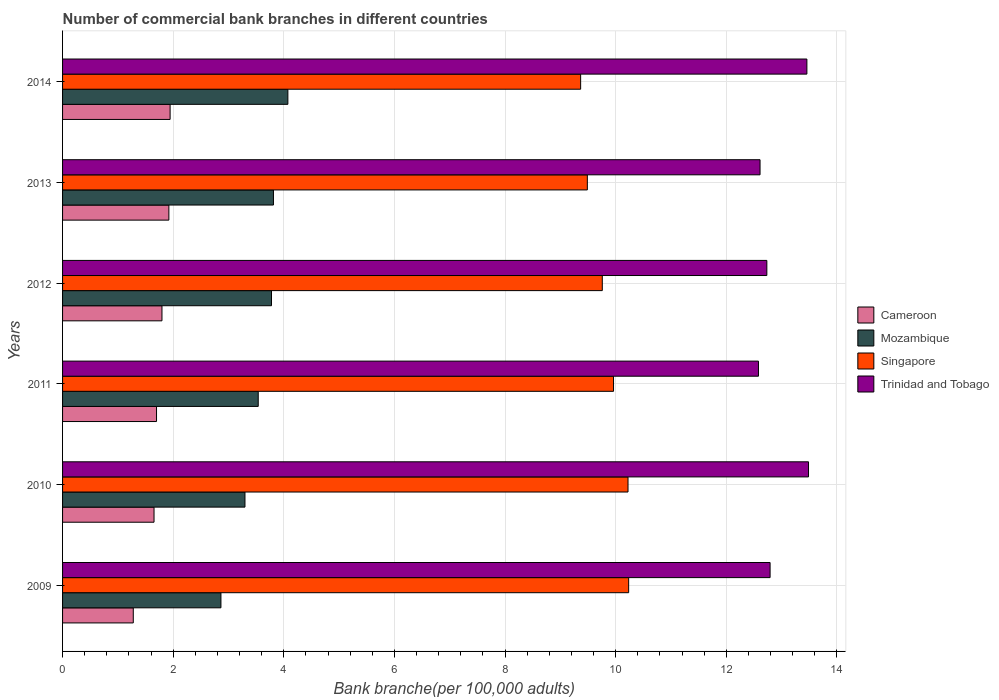How many different coloured bars are there?
Keep it short and to the point. 4. Are the number of bars per tick equal to the number of legend labels?
Provide a succinct answer. Yes. How many bars are there on the 2nd tick from the top?
Provide a succinct answer. 4. How many bars are there on the 2nd tick from the bottom?
Provide a short and direct response. 4. What is the number of commercial bank branches in Singapore in 2009?
Provide a short and direct response. 10.24. Across all years, what is the maximum number of commercial bank branches in Cameroon?
Your answer should be compact. 1.94. Across all years, what is the minimum number of commercial bank branches in Mozambique?
Offer a terse response. 2.86. In which year was the number of commercial bank branches in Singapore maximum?
Offer a terse response. 2009. In which year was the number of commercial bank branches in Mozambique minimum?
Provide a short and direct response. 2009. What is the total number of commercial bank branches in Mozambique in the graph?
Make the answer very short. 21.36. What is the difference between the number of commercial bank branches in Mozambique in 2011 and that in 2014?
Make the answer very short. -0.54. What is the difference between the number of commercial bank branches in Singapore in 2010 and the number of commercial bank branches in Mozambique in 2011?
Give a very brief answer. 6.69. What is the average number of commercial bank branches in Trinidad and Tobago per year?
Keep it short and to the point. 12.94. In the year 2012, what is the difference between the number of commercial bank branches in Trinidad and Tobago and number of commercial bank branches in Cameroon?
Provide a succinct answer. 10.94. In how many years, is the number of commercial bank branches in Singapore greater than 11.6 ?
Ensure brevity in your answer.  0. What is the ratio of the number of commercial bank branches in Trinidad and Tobago in 2009 to that in 2013?
Provide a succinct answer. 1.01. What is the difference between the highest and the second highest number of commercial bank branches in Singapore?
Offer a very short reply. 0.01. What is the difference between the highest and the lowest number of commercial bank branches in Trinidad and Tobago?
Provide a short and direct response. 0.91. In how many years, is the number of commercial bank branches in Mozambique greater than the average number of commercial bank branches in Mozambique taken over all years?
Keep it short and to the point. 3. Is it the case that in every year, the sum of the number of commercial bank branches in Trinidad and Tobago and number of commercial bank branches in Mozambique is greater than the sum of number of commercial bank branches in Singapore and number of commercial bank branches in Cameroon?
Offer a very short reply. Yes. What does the 2nd bar from the top in 2014 represents?
Keep it short and to the point. Singapore. What does the 3rd bar from the bottom in 2012 represents?
Provide a short and direct response. Singapore. How many bars are there?
Offer a terse response. 24. Are all the bars in the graph horizontal?
Provide a succinct answer. Yes. Does the graph contain any zero values?
Offer a very short reply. No. Where does the legend appear in the graph?
Your answer should be compact. Center right. How are the legend labels stacked?
Ensure brevity in your answer.  Vertical. What is the title of the graph?
Offer a very short reply. Number of commercial bank branches in different countries. Does "Afghanistan" appear as one of the legend labels in the graph?
Provide a succinct answer. No. What is the label or title of the X-axis?
Your answer should be very brief. Bank branche(per 100,0 adults). What is the Bank branche(per 100,000 adults) in Cameroon in 2009?
Ensure brevity in your answer.  1.28. What is the Bank branche(per 100,000 adults) of Mozambique in 2009?
Keep it short and to the point. 2.86. What is the Bank branche(per 100,000 adults) of Singapore in 2009?
Ensure brevity in your answer.  10.24. What is the Bank branche(per 100,000 adults) in Trinidad and Tobago in 2009?
Make the answer very short. 12.79. What is the Bank branche(per 100,000 adults) in Cameroon in 2010?
Your response must be concise. 1.65. What is the Bank branche(per 100,000 adults) of Mozambique in 2010?
Your answer should be compact. 3.3. What is the Bank branche(per 100,000 adults) of Singapore in 2010?
Your answer should be very brief. 10.22. What is the Bank branche(per 100,000 adults) of Trinidad and Tobago in 2010?
Your answer should be very brief. 13.49. What is the Bank branche(per 100,000 adults) of Cameroon in 2011?
Give a very brief answer. 1.7. What is the Bank branche(per 100,000 adults) in Mozambique in 2011?
Give a very brief answer. 3.54. What is the Bank branche(per 100,000 adults) in Singapore in 2011?
Give a very brief answer. 9.96. What is the Bank branche(per 100,000 adults) of Trinidad and Tobago in 2011?
Make the answer very short. 12.58. What is the Bank branche(per 100,000 adults) of Cameroon in 2012?
Your answer should be very brief. 1.8. What is the Bank branche(per 100,000 adults) in Mozambique in 2012?
Give a very brief answer. 3.78. What is the Bank branche(per 100,000 adults) in Singapore in 2012?
Offer a very short reply. 9.76. What is the Bank branche(per 100,000 adults) of Trinidad and Tobago in 2012?
Provide a short and direct response. 12.73. What is the Bank branche(per 100,000 adults) in Cameroon in 2013?
Offer a terse response. 1.92. What is the Bank branche(per 100,000 adults) in Mozambique in 2013?
Keep it short and to the point. 3.81. What is the Bank branche(per 100,000 adults) of Singapore in 2013?
Your response must be concise. 9.49. What is the Bank branche(per 100,000 adults) of Trinidad and Tobago in 2013?
Provide a succinct answer. 12.61. What is the Bank branche(per 100,000 adults) of Cameroon in 2014?
Provide a short and direct response. 1.94. What is the Bank branche(per 100,000 adults) in Mozambique in 2014?
Provide a short and direct response. 4.07. What is the Bank branche(per 100,000 adults) in Singapore in 2014?
Ensure brevity in your answer.  9.37. What is the Bank branche(per 100,000 adults) in Trinidad and Tobago in 2014?
Your response must be concise. 13.46. Across all years, what is the maximum Bank branche(per 100,000 adults) of Cameroon?
Give a very brief answer. 1.94. Across all years, what is the maximum Bank branche(per 100,000 adults) of Mozambique?
Give a very brief answer. 4.07. Across all years, what is the maximum Bank branche(per 100,000 adults) in Singapore?
Provide a short and direct response. 10.24. Across all years, what is the maximum Bank branche(per 100,000 adults) in Trinidad and Tobago?
Make the answer very short. 13.49. Across all years, what is the minimum Bank branche(per 100,000 adults) of Cameroon?
Your answer should be compact. 1.28. Across all years, what is the minimum Bank branche(per 100,000 adults) of Mozambique?
Offer a terse response. 2.86. Across all years, what is the minimum Bank branche(per 100,000 adults) of Singapore?
Ensure brevity in your answer.  9.37. Across all years, what is the minimum Bank branche(per 100,000 adults) in Trinidad and Tobago?
Your answer should be very brief. 12.58. What is the total Bank branche(per 100,000 adults) in Cameroon in the graph?
Offer a terse response. 10.3. What is the total Bank branche(per 100,000 adults) in Mozambique in the graph?
Keep it short and to the point. 21.36. What is the total Bank branche(per 100,000 adults) in Singapore in the graph?
Give a very brief answer. 59.03. What is the total Bank branche(per 100,000 adults) in Trinidad and Tobago in the graph?
Provide a succinct answer. 77.66. What is the difference between the Bank branche(per 100,000 adults) in Cameroon in 2009 and that in 2010?
Keep it short and to the point. -0.38. What is the difference between the Bank branche(per 100,000 adults) of Mozambique in 2009 and that in 2010?
Provide a succinct answer. -0.43. What is the difference between the Bank branche(per 100,000 adults) in Singapore in 2009 and that in 2010?
Offer a very short reply. 0.01. What is the difference between the Bank branche(per 100,000 adults) of Trinidad and Tobago in 2009 and that in 2010?
Your response must be concise. -0.69. What is the difference between the Bank branche(per 100,000 adults) in Cameroon in 2009 and that in 2011?
Your answer should be very brief. -0.42. What is the difference between the Bank branche(per 100,000 adults) of Mozambique in 2009 and that in 2011?
Your answer should be very brief. -0.67. What is the difference between the Bank branche(per 100,000 adults) of Singapore in 2009 and that in 2011?
Your response must be concise. 0.27. What is the difference between the Bank branche(per 100,000 adults) in Trinidad and Tobago in 2009 and that in 2011?
Keep it short and to the point. 0.21. What is the difference between the Bank branche(per 100,000 adults) in Cameroon in 2009 and that in 2012?
Make the answer very short. -0.52. What is the difference between the Bank branche(per 100,000 adults) in Mozambique in 2009 and that in 2012?
Offer a very short reply. -0.91. What is the difference between the Bank branche(per 100,000 adults) of Singapore in 2009 and that in 2012?
Give a very brief answer. 0.48. What is the difference between the Bank branche(per 100,000 adults) of Trinidad and Tobago in 2009 and that in 2012?
Your response must be concise. 0.06. What is the difference between the Bank branche(per 100,000 adults) of Cameroon in 2009 and that in 2013?
Provide a short and direct response. -0.64. What is the difference between the Bank branche(per 100,000 adults) of Mozambique in 2009 and that in 2013?
Keep it short and to the point. -0.95. What is the difference between the Bank branche(per 100,000 adults) of Singapore in 2009 and that in 2013?
Give a very brief answer. 0.75. What is the difference between the Bank branche(per 100,000 adults) in Trinidad and Tobago in 2009 and that in 2013?
Provide a succinct answer. 0.18. What is the difference between the Bank branche(per 100,000 adults) of Cameroon in 2009 and that in 2014?
Give a very brief answer. -0.67. What is the difference between the Bank branche(per 100,000 adults) in Mozambique in 2009 and that in 2014?
Offer a terse response. -1.21. What is the difference between the Bank branche(per 100,000 adults) of Singapore in 2009 and that in 2014?
Provide a short and direct response. 0.87. What is the difference between the Bank branche(per 100,000 adults) in Trinidad and Tobago in 2009 and that in 2014?
Provide a short and direct response. -0.67. What is the difference between the Bank branche(per 100,000 adults) in Cameroon in 2010 and that in 2011?
Keep it short and to the point. -0.05. What is the difference between the Bank branche(per 100,000 adults) in Mozambique in 2010 and that in 2011?
Your answer should be compact. -0.24. What is the difference between the Bank branche(per 100,000 adults) in Singapore in 2010 and that in 2011?
Provide a succinct answer. 0.26. What is the difference between the Bank branche(per 100,000 adults) of Trinidad and Tobago in 2010 and that in 2011?
Ensure brevity in your answer.  0.91. What is the difference between the Bank branche(per 100,000 adults) of Cameroon in 2010 and that in 2012?
Offer a very short reply. -0.14. What is the difference between the Bank branche(per 100,000 adults) of Mozambique in 2010 and that in 2012?
Your answer should be very brief. -0.48. What is the difference between the Bank branche(per 100,000 adults) of Singapore in 2010 and that in 2012?
Your answer should be very brief. 0.46. What is the difference between the Bank branche(per 100,000 adults) of Trinidad and Tobago in 2010 and that in 2012?
Your answer should be compact. 0.75. What is the difference between the Bank branche(per 100,000 adults) of Cameroon in 2010 and that in 2013?
Keep it short and to the point. -0.27. What is the difference between the Bank branche(per 100,000 adults) in Mozambique in 2010 and that in 2013?
Offer a very short reply. -0.51. What is the difference between the Bank branche(per 100,000 adults) of Singapore in 2010 and that in 2013?
Make the answer very short. 0.74. What is the difference between the Bank branche(per 100,000 adults) of Trinidad and Tobago in 2010 and that in 2013?
Your answer should be very brief. 0.88. What is the difference between the Bank branche(per 100,000 adults) of Cameroon in 2010 and that in 2014?
Your answer should be compact. -0.29. What is the difference between the Bank branche(per 100,000 adults) in Mozambique in 2010 and that in 2014?
Keep it short and to the point. -0.78. What is the difference between the Bank branche(per 100,000 adults) in Singapore in 2010 and that in 2014?
Provide a succinct answer. 0.86. What is the difference between the Bank branche(per 100,000 adults) of Trinidad and Tobago in 2010 and that in 2014?
Provide a short and direct response. 0.03. What is the difference between the Bank branche(per 100,000 adults) in Cameroon in 2011 and that in 2012?
Provide a succinct answer. -0.1. What is the difference between the Bank branche(per 100,000 adults) of Mozambique in 2011 and that in 2012?
Offer a terse response. -0.24. What is the difference between the Bank branche(per 100,000 adults) in Singapore in 2011 and that in 2012?
Keep it short and to the point. 0.2. What is the difference between the Bank branche(per 100,000 adults) of Trinidad and Tobago in 2011 and that in 2012?
Your answer should be compact. -0.15. What is the difference between the Bank branche(per 100,000 adults) of Cameroon in 2011 and that in 2013?
Ensure brevity in your answer.  -0.22. What is the difference between the Bank branche(per 100,000 adults) in Mozambique in 2011 and that in 2013?
Your answer should be very brief. -0.28. What is the difference between the Bank branche(per 100,000 adults) in Singapore in 2011 and that in 2013?
Your response must be concise. 0.47. What is the difference between the Bank branche(per 100,000 adults) of Trinidad and Tobago in 2011 and that in 2013?
Your answer should be compact. -0.03. What is the difference between the Bank branche(per 100,000 adults) in Cameroon in 2011 and that in 2014?
Provide a short and direct response. -0.25. What is the difference between the Bank branche(per 100,000 adults) of Mozambique in 2011 and that in 2014?
Your response must be concise. -0.54. What is the difference between the Bank branche(per 100,000 adults) of Singapore in 2011 and that in 2014?
Your response must be concise. 0.59. What is the difference between the Bank branche(per 100,000 adults) of Trinidad and Tobago in 2011 and that in 2014?
Give a very brief answer. -0.88. What is the difference between the Bank branche(per 100,000 adults) in Cameroon in 2012 and that in 2013?
Provide a succinct answer. -0.12. What is the difference between the Bank branche(per 100,000 adults) in Mozambique in 2012 and that in 2013?
Provide a succinct answer. -0.04. What is the difference between the Bank branche(per 100,000 adults) in Singapore in 2012 and that in 2013?
Provide a succinct answer. 0.27. What is the difference between the Bank branche(per 100,000 adults) in Trinidad and Tobago in 2012 and that in 2013?
Offer a terse response. 0.12. What is the difference between the Bank branche(per 100,000 adults) of Cameroon in 2012 and that in 2014?
Your answer should be compact. -0.15. What is the difference between the Bank branche(per 100,000 adults) of Mozambique in 2012 and that in 2014?
Offer a very short reply. -0.3. What is the difference between the Bank branche(per 100,000 adults) of Singapore in 2012 and that in 2014?
Your answer should be compact. 0.39. What is the difference between the Bank branche(per 100,000 adults) in Trinidad and Tobago in 2012 and that in 2014?
Give a very brief answer. -0.72. What is the difference between the Bank branche(per 100,000 adults) in Cameroon in 2013 and that in 2014?
Provide a succinct answer. -0.02. What is the difference between the Bank branche(per 100,000 adults) of Mozambique in 2013 and that in 2014?
Give a very brief answer. -0.26. What is the difference between the Bank branche(per 100,000 adults) of Singapore in 2013 and that in 2014?
Provide a short and direct response. 0.12. What is the difference between the Bank branche(per 100,000 adults) of Trinidad and Tobago in 2013 and that in 2014?
Offer a very short reply. -0.85. What is the difference between the Bank branche(per 100,000 adults) in Cameroon in 2009 and the Bank branche(per 100,000 adults) in Mozambique in 2010?
Make the answer very short. -2.02. What is the difference between the Bank branche(per 100,000 adults) of Cameroon in 2009 and the Bank branche(per 100,000 adults) of Singapore in 2010?
Your response must be concise. -8.94. What is the difference between the Bank branche(per 100,000 adults) of Cameroon in 2009 and the Bank branche(per 100,000 adults) of Trinidad and Tobago in 2010?
Ensure brevity in your answer.  -12.21. What is the difference between the Bank branche(per 100,000 adults) of Mozambique in 2009 and the Bank branche(per 100,000 adults) of Singapore in 2010?
Give a very brief answer. -7.36. What is the difference between the Bank branche(per 100,000 adults) in Mozambique in 2009 and the Bank branche(per 100,000 adults) in Trinidad and Tobago in 2010?
Ensure brevity in your answer.  -10.62. What is the difference between the Bank branche(per 100,000 adults) in Singapore in 2009 and the Bank branche(per 100,000 adults) in Trinidad and Tobago in 2010?
Ensure brevity in your answer.  -3.25. What is the difference between the Bank branche(per 100,000 adults) of Cameroon in 2009 and the Bank branche(per 100,000 adults) of Mozambique in 2011?
Your response must be concise. -2.26. What is the difference between the Bank branche(per 100,000 adults) in Cameroon in 2009 and the Bank branche(per 100,000 adults) in Singapore in 2011?
Your answer should be very brief. -8.68. What is the difference between the Bank branche(per 100,000 adults) in Cameroon in 2009 and the Bank branche(per 100,000 adults) in Trinidad and Tobago in 2011?
Provide a short and direct response. -11.3. What is the difference between the Bank branche(per 100,000 adults) in Mozambique in 2009 and the Bank branche(per 100,000 adults) in Singapore in 2011?
Your response must be concise. -7.1. What is the difference between the Bank branche(per 100,000 adults) in Mozambique in 2009 and the Bank branche(per 100,000 adults) in Trinidad and Tobago in 2011?
Offer a very short reply. -9.72. What is the difference between the Bank branche(per 100,000 adults) in Singapore in 2009 and the Bank branche(per 100,000 adults) in Trinidad and Tobago in 2011?
Your answer should be compact. -2.35. What is the difference between the Bank branche(per 100,000 adults) in Cameroon in 2009 and the Bank branche(per 100,000 adults) in Mozambique in 2012?
Offer a terse response. -2.5. What is the difference between the Bank branche(per 100,000 adults) of Cameroon in 2009 and the Bank branche(per 100,000 adults) of Singapore in 2012?
Make the answer very short. -8.48. What is the difference between the Bank branche(per 100,000 adults) of Cameroon in 2009 and the Bank branche(per 100,000 adults) of Trinidad and Tobago in 2012?
Offer a terse response. -11.46. What is the difference between the Bank branche(per 100,000 adults) in Mozambique in 2009 and the Bank branche(per 100,000 adults) in Singapore in 2012?
Your answer should be compact. -6.89. What is the difference between the Bank branche(per 100,000 adults) in Mozambique in 2009 and the Bank branche(per 100,000 adults) in Trinidad and Tobago in 2012?
Your answer should be very brief. -9.87. What is the difference between the Bank branche(per 100,000 adults) in Singapore in 2009 and the Bank branche(per 100,000 adults) in Trinidad and Tobago in 2012?
Keep it short and to the point. -2.5. What is the difference between the Bank branche(per 100,000 adults) in Cameroon in 2009 and the Bank branche(per 100,000 adults) in Mozambique in 2013?
Provide a succinct answer. -2.53. What is the difference between the Bank branche(per 100,000 adults) of Cameroon in 2009 and the Bank branche(per 100,000 adults) of Singapore in 2013?
Offer a very short reply. -8.21. What is the difference between the Bank branche(per 100,000 adults) of Cameroon in 2009 and the Bank branche(per 100,000 adults) of Trinidad and Tobago in 2013?
Provide a succinct answer. -11.33. What is the difference between the Bank branche(per 100,000 adults) of Mozambique in 2009 and the Bank branche(per 100,000 adults) of Singapore in 2013?
Give a very brief answer. -6.62. What is the difference between the Bank branche(per 100,000 adults) in Mozambique in 2009 and the Bank branche(per 100,000 adults) in Trinidad and Tobago in 2013?
Your answer should be compact. -9.75. What is the difference between the Bank branche(per 100,000 adults) of Singapore in 2009 and the Bank branche(per 100,000 adults) of Trinidad and Tobago in 2013?
Your answer should be compact. -2.38. What is the difference between the Bank branche(per 100,000 adults) in Cameroon in 2009 and the Bank branche(per 100,000 adults) in Mozambique in 2014?
Provide a succinct answer. -2.79. What is the difference between the Bank branche(per 100,000 adults) of Cameroon in 2009 and the Bank branche(per 100,000 adults) of Singapore in 2014?
Provide a short and direct response. -8.09. What is the difference between the Bank branche(per 100,000 adults) in Cameroon in 2009 and the Bank branche(per 100,000 adults) in Trinidad and Tobago in 2014?
Give a very brief answer. -12.18. What is the difference between the Bank branche(per 100,000 adults) of Mozambique in 2009 and the Bank branche(per 100,000 adults) of Singapore in 2014?
Make the answer very short. -6.5. What is the difference between the Bank branche(per 100,000 adults) of Mozambique in 2009 and the Bank branche(per 100,000 adults) of Trinidad and Tobago in 2014?
Ensure brevity in your answer.  -10.59. What is the difference between the Bank branche(per 100,000 adults) in Singapore in 2009 and the Bank branche(per 100,000 adults) in Trinidad and Tobago in 2014?
Offer a very short reply. -3.22. What is the difference between the Bank branche(per 100,000 adults) in Cameroon in 2010 and the Bank branche(per 100,000 adults) in Mozambique in 2011?
Offer a terse response. -1.88. What is the difference between the Bank branche(per 100,000 adults) in Cameroon in 2010 and the Bank branche(per 100,000 adults) in Singapore in 2011?
Offer a very short reply. -8.31. What is the difference between the Bank branche(per 100,000 adults) of Cameroon in 2010 and the Bank branche(per 100,000 adults) of Trinidad and Tobago in 2011?
Give a very brief answer. -10.93. What is the difference between the Bank branche(per 100,000 adults) of Mozambique in 2010 and the Bank branche(per 100,000 adults) of Singapore in 2011?
Ensure brevity in your answer.  -6.66. What is the difference between the Bank branche(per 100,000 adults) in Mozambique in 2010 and the Bank branche(per 100,000 adults) in Trinidad and Tobago in 2011?
Your answer should be very brief. -9.28. What is the difference between the Bank branche(per 100,000 adults) of Singapore in 2010 and the Bank branche(per 100,000 adults) of Trinidad and Tobago in 2011?
Your answer should be compact. -2.36. What is the difference between the Bank branche(per 100,000 adults) in Cameroon in 2010 and the Bank branche(per 100,000 adults) in Mozambique in 2012?
Offer a very short reply. -2.12. What is the difference between the Bank branche(per 100,000 adults) in Cameroon in 2010 and the Bank branche(per 100,000 adults) in Singapore in 2012?
Give a very brief answer. -8.1. What is the difference between the Bank branche(per 100,000 adults) of Cameroon in 2010 and the Bank branche(per 100,000 adults) of Trinidad and Tobago in 2012?
Your answer should be compact. -11.08. What is the difference between the Bank branche(per 100,000 adults) in Mozambique in 2010 and the Bank branche(per 100,000 adults) in Singapore in 2012?
Your response must be concise. -6.46. What is the difference between the Bank branche(per 100,000 adults) in Mozambique in 2010 and the Bank branche(per 100,000 adults) in Trinidad and Tobago in 2012?
Your answer should be very brief. -9.44. What is the difference between the Bank branche(per 100,000 adults) of Singapore in 2010 and the Bank branche(per 100,000 adults) of Trinidad and Tobago in 2012?
Ensure brevity in your answer.  -2.51. What is the difference between the Bank branche(per 100,000 adults) of Cameroon in 2010 and the Bank branche(per 100,000 adults) of Mozambique in 2013?
Give a very brief answer. -2.16. What is the difference between the Bank branche(per 100,000 adults) of Cameroon in 2010 and the Bank branche(per 100,000 adults) of Singapore in 2013?
Ensure brevity in your answer.  -7.83. What is the difference between the Bank branche(per 100,000 adults) of Cameroon in 2010 and the Bank branche(per 100,000 adults) of Trinidad and Tobago in 2013?
Your answer should be compact. -10.96. What is the difference between the Bank branche(per 100,000 adults) in Mozambique in 2010 and the Bank branche(per 100,000 adults) in Singapore in 2013?
Give a very brief answer. -6.19. What is the difference between the Bank branche(per 100,000 adults) of Mozambique in 2010 and the Bank branche(per 100,000 adults) of Trinidad and Tobago in 2013?
Your answer should be compact. -9.31. What is the difference between the Bank branche(per 100,000 adults) of Singapore in 2010 and the Bank branche(per 100,000 adults) of Trinidad and Tobago in 2013?
Make the answer very short. -2.39. What is the difference between the Bank branche(per 100,000 adults) in Cameroon in 2010 and the Bank branche(per 100,000 adults) in Mozambique in 2014?
Ensure brevity in your answer.  -2.42. What is the difference between the Bank branche(per 100,000 adults) in Cameroon in 2010 and the Bank branche(per 100,000 adults) in Singapore in 2014?
Offer a terse response. -7.71. What is the difference between the Bank branche(per 100,000 adults) in Cameroon in 2010 and the Bank branche(per 100,000 adults) in Trinidad and Tobago in 2014?
Give a very brief answer. -11.8. What is the difference between the Bank branche(per 100,000 adults) of Mozambique in 2010 and the Bank branche(per 100,000 adults) of Singapore in 2014?
Keep it short and to the point. -6.07. What is the difference between the Bank branche(per 100,000 adults) of Mozambique in 2010 and the Bank branche(per 100,000 adults) of Trinidad and Tobago in 2014?
Give a very brief answer. -10.16. What is the difference between the Bank branche(per 100,000 adults) of Singapore in 2010 and the Bank branche(per 100,000 adults) of Trinidad and Tobago in 2014?
Make the answer very short. -3.23. What is the difference between the Bank branche(per 100,000 adults) in Cameroon in 2011 and the Bank branche(per 100,000 adults) in Mozambique in 2012?
Your response must be concise. -2.08. What is the difference between the Bank branche(per 100,000 adults) of Cameroon in 2011 and the Bank branche(per 100,000 adults) of Singapore in 2012?
Your answer should be compact. -8.06. What is the difference between the Bank branche(per 100,000 adults) in Cameroon in 2011 and the Bank branche(per 100,000 adults) in Trinidad and Tobago in 2012?
Provide a succinct answer. -11.03. What is the difference between the Bank branche(per 100,000 adults) in Mozambique in 2011 and the Bank branche(per 100,000 adults) in Singapore in 2012?
Your answer should be very brief. -6.22. What is the difference between the Bank branche(per 100,000 adults) in Mozambique in 2011 and the Bank branche(per 100,000 adults) in Trinidad and Tobago in 2012?
Give a very brief answer. -9.2. What is the difference between the Bank branche(per 100,000 adults) of Singapore in 2011 and the Bank branche(per 100,000 adults) of Trinidad and Tobago in 2012?
Give a very brief answer. -2.77. What is the difference between the Bank branche(per 100,000 adults) of Cameroon in 2011 and the Bank branche(per 100,000 adults) of Mozambique in 2013?
Offer a terse response. -2.11. What is the difference between the Bank branche(per 100,000 adults) in Cameroon in 2011 and the Bank branche(per 100,000 adults) in Singapore in 2013?
Keep it short and to the point. -7.79. What is the difference between the Bank branche(per 100,000 adults) in Cameroon in 2011 and the Bank branche(per 100,000 adults) in Trinidad and Tobago in 2013?
Make the answer very short. -10.91. What is the difference between the Bank branche(per 100,000 adults) in Mozambique in 2011 and the Bank branche(per 100,000 adults) in Singapore in 2013?
Ensure brevity in your answer.  -5.95. What is the difference between the Bank branche(per 100,000 adults) in Mozambique in 2011 and the Bank branche(per 100,000 adults) in Trinidad and Tobago in 2013?
Your response must be concise. -9.07. What is the difference between the Bank branche(per 100,000 adults) of Singapore in 2011 and the Bank branche(per 100,000 adults) of Trinidad and Tobago in 2013?
Make the answer very short. -2.65. What is the difference between the Bank branche(per 100,000 adults) of Cameroon in 2011 and the Bank branche(per 100,000 adults) of Mozambique in 2014?
Your answer should be very brief. -2.37. What is the difference between the Bank branche(per 100,000 adults) in Cameroon in 2011 and the Bank branche(per 100,000 adults) in Singapore in 2014?
Offer a terse response. -7.67. What is the difference between the Bank branche(per 100,000 adults) in Cameroon in 2011 and the Bank branche(per 100,000 adults) in Trinidad and Tobago in 2014?
Your answer should be very brief. -11.76. What is the difference between the Bank branche(per 100,000 adults) in Mozambique in 2011 and the Bank branche(per 100,000 adults) in Singapore in 2014?
Provide a succinct answer. -5.83. What is the difference between the Bank branche(per 100,000 adults) in Mozambique in 2011 and the Bank branche(per 100,000 adults) in Trinidad and Tobago in 2014?
Your response must be concise. -9.92. What is the difference between the Bank branche(per 100,000 adults) in Singapore in 2011 and the Bank branche(per 100,000 adults) in Trinidad and Tobago in 2014?
Give a very brief answer. -3.5. What is the difference between the Bank branche(per 100,000 adults) in Cameroon in 2012 and the Bank branche(per 100,000 adults) in Mozambique in 2013?
Your response must be concise. -2.02. What is the difference between the Bank branche(per 100,000 adults) in Cameroon in 2012 and the Bank branche(per 100,000 adults) in Singapore in 2013?
Keep it short and to the point. -7.69. What is the difference between the Bank branche(per 100,000 adults) in Cameroon in 2012 and the Bank branche(per 100,000 adults) in Trinidad and Tobago in 2013?
Your response must be concise. -10.81. What is the difference between the Bank branche(per 100,000 adults) in Mozambique in 2012 and the Bank branche(per 100,000 adults) in Singapore in 2013?
Your response must be concise. -5.71. What is the difference between the Bank branche(per 100,000 adults) of Mozambique in 2012 and the Bank branche(per 100,000 adults) of Trinidad and Tobago in 2013?
Ensure brevity in your answer.  -8.83. What is the difference between the Bank branche(per 100,000 adults) in Singapore in 2012 and the Bank branche(per 100,000 adults) in Trinidad and Tobago in 2013?
Give a very brief answer. -2.85. What is the difference between the Bank branche(per 100,000 adults) in Cameroon in 2012 and the Bank branche(per 100,000 adults) in Mozambique in 2014?
Offer a very short reply. -2.28. What is the difference between the Bank branche(per 100,000 adults) in Cameroon in 2012 and the Bank branche(per 100,000 adults) in Singapore in 2014?
Ensure brevity in your answer.  -7.57. What is the difference between the Bank branche(per 100,000 adults) in Cameroon in 2012 and the Bank branche(per 100,000 adults) in Trinidad and Tobago in 2014?
Offer a very short reply. -11.66. What is the difference between the Bank branche(per 100,000 adults) in Mozambique in 2012 and the Bank branche(per 100,000 adults) in Singapore in 2014?
Your response must be concise. -5.59. What is the difference between the Bank branche(per 100,000 adults) in Mozambique in 2012 and the Bank branche(per 100,000 adults) in Trinidad and Tobago in 2014?
Your answer should be compact. -9.68. What is the difference between the Bank branche(per 100,000 adults) of Singapore in 2012 and the Bank branche(per 100,000 adults) of Trinidad and Tobago in 2014?
Your answer should be compact. -3.7. What is the difference between the Bank branche(per 100,000 adults) of Cameroon in 2013 and the Bank branche(per 100,000 adults) of Mozambique in 2014?
Provide a short and direct response. -2.15. What is the difference between the Bank branche(per 100,000 adults) of Cameroon in 2013 and the Bank branche(per 100,000 adults) of Singapore in 2014?
Your answer should be compact. -7.44. What is the difference between the Bank branche(per 100,000 adults) of Cameroon in 2013 and the Bank branche(per 100,000 adults) of Trinidad and Tobago in 2014?
Your answer should be compact. -11.54. What is the difference between the Bank branche(per 100,000 adults) of Mozambique in 2013 and the Bank branche(per 100,000 adults) of Singapore in 2014?
Provide a short and direct response. -5.55. What is the difference between the Bank branche(per 100,000 adults) in Mozambique in 2013 and the Bank branche(per 100,000 adults) in Trinidad and Tobago in 2014?
Keep it short and to the point. -9.64. What is the difference between the Bank branche(per 100,000 adults) in Singapore in 2013 and the Bank branche(per 100,000 adults) in Trinidad and Tobago in 2014?
Keep it short and to the point. -3.97. What is the average Bank branche(per 100,000 adults) in Cameroon per year?
Provide a short and direct response. 1.72. What is the average Bank branche(per 100,000 adults) in Mozambique per year?
Your answer should be very brief. 3.56. What is the average Bank branche(per 100,000 adults) in Singapore per year?
Your response must be concise. 9.84. What is the average Bank branche(per 100,000 adults) in Trinidad and Tobago per year?
Provide a short and direct response. 12.94. In the year 2009, what is the difference between the Bank branche(per 100,000 adults) of Cameroon and Bank branche(per 100,000 adults) of Mozambique?
Offer a terse response. -1.58. In the year 2009, what is the difference between the Bank branche(per 100,000 adults) of Cameroon and Bank branche(per 100,000 adults) of Singapore?
Keep it short and to the point. -8.96. In the year 2009, what is the difference between the Bank branche(per 100,000 adults) of Cameroon and Bank branche(per 100,000 adults) of Trinidad and Tobago?
Provide a short and direct response. -11.51. In the year 2009, what is the difference between the Bank branche(per 100,000 adults) in Mozambique and Bank branche(per 100,000 adults) in Singapore?
Offer a very short reply. -7.37. In the year 2009, what is the difference between the Bank branche(per 100,000 adults) of Mozambique and Bank branche(per 100,000 adults) of Trinidad and Tobago?
Your answer should be very brief. -9.93. In the year 2009, what is the difference between the Bank branche(per 100,000 adults) of Singapore and Bank branche(per 100,000 adults) of Trinidad and Tobago?
Your answer should be compact. -2.56. In the year 2010, what is the difference between the Bank branche(per 100,000 adults) in Cameroon and Bank branche(per 100,000 adults) in Mozambique?
Your answer should be very brief. -1.64. In the year 2010, what is the difference between the Bank branche(per 100,000 adults) of Cameroon and Bank branche(per 100,000 adults) of Singapore?
Your answer should be very brief. -8.57. In the year 2010, what is the difference between the Bank branche(per 100,000 adults) in Cameroon and Bank branche(per 100,000 adults) in Trinidad and Tobago?
Ensure brevity in your answer.  -11.83. In the year 2010, what is the difference between the Bank branche(per 100,000 adults) of Mozambique and Bank branche(per 100,000 adults) of Singapore?
Make the answer very short. -6.93. In the year 2010, what is the difference between the Bank branche(per 100,000 adults) of Mozambique and Bank branche(per 100,000 adults) of Trinidad and Tobago?
Offer a terse response. -10.19. In the year 2010, what is the difference between the Bank branche(per 100,000 adults) of Singapore and Bank branche(per 100,000 adults) of Trinidad and Tobago?
Give a very brief answer. -3.26. In the year 2011, what is the difference between the Bank branche(per 100,000 adults) in Cameroon and Bank branche(per 100,000 adults) in Mozambique?
Give a very brief answer. -1.84. In the year 2011, what is the difference between the Bank branche(per 100,000 adults) of Cameroon and Bank branche(per 100,000 adults) of Singapore?
Provide a short and direct response. -8.26. In the year 2011, what is the difference between the Bank branche(per 100,000 adults) in Cameroon and Bank branche(per 100,000 adults) in Trinidad and Tobago?
Your answer should be very brief. -10.88. In the year 2011, what is the difference between the Bank branche(per 100,000 adults) of Mozambique and Bank branche(per 100,000 adults) of Singapore?
Ensure brevity in your answer.  -6.42. In the year 2011, what is the difference between the Bank branche(per 100,000 adults) of Mozambique and Bank branche(per 100,000 adults) of Trinidad and Tobago?
Offer a terse response. -9.04. In the year 2011, what is the difference between the Bank branche(per 100,000 adults) of Singapore and Bank branche(per 100,000 adults) of Trinidad and Tobago?
Offer a terse response. -2.62. In the year 2012, what is the difference between the Bank branche(per 100,000 adults) in Cameroon and Bank branche(per 100,000 adults) in Mozambique?
Offer a very short reply. -1.98. In the year 2012, what is the difference between the Bank branche(per 100,000 adults) of Cameroon and Bank branche(per 100,000 adults) of Singapore?
Your answer should be very brief. -7.96. In the year 2012, what is the difference between the Bank branche(per 100,000 adults) of Cameroon and Bank branche(per 100,000 adults) of Trinidad and Tobago?
Your answer should be compact. -10.94. In the year 2012, what is the difference between the Bank branche(per 100,000 adults) of Mozambique and Bank branche(per 100,000 adults) of Singapore?
Your answer should be very brief. -5.98. In the year 2012, what is the difference between the Bank branche(per 100,000 adults) of Mozambique and Bank branche(per 100,000 adults) of Trinidad and Tobago?
Give a very brief answer. -8.96. In the year 2012, what is the difference between the Bank branche(per 100,000 adults) in Singapore and Bank branche(per 100,000 adults) in Trinidad and Tobago?
Ensure brevity in your answer.  -2.98. In the year 2013, what is the difference between the Bank branche(per 100,000 adults) in Cameroon and Bank branche(per 100,000 adults) in Mozambique?
Ensure brevity in your answer.  -1.89. In the year 2013, what is the difference between the Bank branche(per 100,000 adults) of Cameroon and Bank branche(per 100,000 adults) of Singapore?
Your answer should be compact. -7.57. In the year 2013, what is the difference between the Bank branche(per 100,000 adults) of Cameroon and Bank branche(per 100,000 adults) of Trinidad and Tobago?
Keep it short and to the point. -10.69. In the year 2013, what is the difference between the Bank branche(per 100,000 adults) of Mozambique and Bank branche(per 100,000 adults) of Singapore?
Provide a succinct answer. -5.68. In the year 2013, what is the difference between the Bank branche(per 100,000 adults) in Mozambique and Bank branche(per 100,000 adults) in Trinidad and Tobago?
Make the answer very short. -8.8. In the year 2013, what is the difference between the Bank branche(per 100,000 adults) of Singapore and Bank branche(per 100,000 adults) of Trinidad and Tobago?
Ensure brevity in your answer.  -3.12. In the year 2014, what is the difference between the Bank branche(per 100,000 adults) in Cameroon and Bank branche(per 100,000 adults) in Mozambique?
Your answer should be compact. -2.13. In the year 2014, what is the difference between the Bank branche(per 100,000 adults) of Cameroon and Bank branche(per 100,000 adults) of Singapore?
Provide a short and direct response. -7.42. In the year 2014, what is the difference between the Bank branche(per 100,000 adults) of Cameroon and Bank branche(per 100,000 adults) of Trinidad and Tobago?
Provide a short and direct response. -11.51. In the year 2014, what is the difference between the Bank branche(per 100,000 adults) in Mozambique and Bank branche(per 100,000 adults) in Singapore?
Provide a succinct answer. -5.29. In the year 2014, what is the difference between the Bank branche(per 100,000 adults) of Mozambique and Bank branche(per 100,000 adults) of Trinidad and Tobago?
Provide a succinct answer. -9.38. In the year 2014, what is the difference between the Bank branche(per 100,000 adults) in Singapore and Bank branche(per 100,000 adults) in Trinidad and Tobago?
Your answer should be compact. -4.09. What is the ratio of the Bank branche(per 100,000 adults) in Cameroon in 2009 to that in 2010?
Ensure brevity in your answer.  0.77. What is the ratio of the Bank branche(per 100,000 adults) of Mozambique in 2009 to that in 2010?
Your response must be concise. 0.87. What is the ratio of the Bank branche(per 100,000 adults) of Singapore in 2009 to that in 2010?
Give a very brief answer. 1. What is the ratio of the Bank branche(per 100,000 adults) of Trinidad and Tobago in 2009 to that in 2010?
Ensure brevity in your answer.  0.95. What is the ratio of the Bank branche(per 100,000 adults) in Cameroon in 2009 to that in 2011?
Make the answer very short. 0.75. What is the ratio of the Bank branche(per 100,000 adults) in Mozambique in 2009 to that in 2011?
Your answer should be compact. 0.81. What is the ratio of the Bank branche(per 100,000 adults) in Singapore in 2009 to that in 2011?
Your response must be concise. 1.03. What is the ratio of the Bank branche(per 100,000 adults) in Trinidad and Tobago in 2009 to that in 2011?
Offer a terse response. 1.02. What is the ratio of the Bank branche(per 100,000 adults) in Cameroon in 2009 to that in 2012?
Your answer should be compact. 0.71. What is the ratio of the Bank branche(per 100,000 adults) in Mozambique in 2009 to that in 2012?
Provide a succinct answer. 0.76. What is the ratio of the Bank branche(per 100,000 adults) of Singapore in 2009 to that in 2012?
Offer a terse response. 1.05. What is the ratio of the Bank branche(per 100,000 adults) of Trinidad and Tobago in 2009 to that in 2012?
Provide a succinct answer. 1. What is the ratio of the Bank branche(per 100,000 adults) of Cameroon in 2009 to that in 2013?
Your response must be concise. 0.67. What is the ratio of the Bank branche(per 100,000 adults) in Mozambique in 2009 to that in 2013?
Your answer should be very brief. 0.75. What is the ratio of the Bank branche(per 100,000 adults) of Singapore in 2009 to that in 2013?
Offer a terse response. 1.08. What is the ratio of the Bank branche(per 100,000 adults) in Trinidad and Tobago in 2009 to that in 2013?
Make the answer very short. 1.01. What is the ratio of the Bank branche(per 100,000 adults) of Cameroon in 2009 to that in 2014?
Provide a short and direct response. 0.66. What is the ratio of the Bank branche(per 100,000 adults) of Mozambique in 2009 to that in 2014?
Your answer should be very brief. 0.7. What is the ratio of the Bank branche(per 100,000 adults) of Singapore in 2009 to that in 2014?
Provide a short and direct response. 1.09. What is the ratio of the Bank branche(per 100,000 adults) of Trinidad and Tobago in 2009 to that in 2014?
Your answer should be very brief. 0.95. What is the ratio of the Bank branche(per 100,000 adults) in Cameroon in 2010 to that in 2011?
Your answer should be compact. 0.97. What is the ratio of the Bank branche(per 100,000 adults) of Mozambique in 2010 to that in 2011?
Your answer should be compact. 0.93. What is the ratio of the Bank branche(per 100,000 adults) of Singapore in 2010 to that in 2011?
Give a very brief answer. 1.03. What is the ratio of the Bank branche(per 100,000 adults) of Trinidad and Tobago in 2010 to that in 2011?
Provide a short and direct response. 1.07. What is the ratio of the Bank branche(per 100,000 adults) of Cameroon in 2010 to that in 2012?
Ensure brevity in your answer.  0.92. What is the ratio of the Bank branche(per 100,000 adults) of Mozambique in 2010 to that in 2012?
Make the answer very short. 0.87. What is the ratio of the Bank branche(per 100,000 adults) in Singapore in 2010 to that in 2012?
Your response must be concise. 1.05. What is the ratio of the Bank branche(per 100,000 adults) in Trinidad and Tobago in 2010 to that in 2012?
Offer a very short reply. 1.06. What is the ratio of the Bank branche(per 100,000 adults) in Cameroon in 2010 to that in 2013?
Your answer should be very brief. 0.86. What is the ratio of the Bank branche(per 100,000 adults) of Mozambique in 2010 to that in 2013?
Ensure brevity in your answer.  0.86. What is the ratio of the Bank branche(per 100,000 adults) in Singapore in 2010 to that in 2013?
Your answer should be compact. 1.08. What is the ratio of the Bank branche(per 100,000 adults) of Trinidad and Tobago in 2010 to that in 2013?
Your answer should be very brief. 1.07. What is the ratio of the Bank branche(per 100,000 adults) of Cameroon in 2010 to that in 2014?
Make the answer very short. 0.85. What is the ratio of the Bank branche(per 100,000 adults) of Mozambique in 2010 to that in 2014?
Give a very brief answer. 0.81. What is the ratio of the Bank branche(per 100,000 adults) in Singapore in 2010 to that in 2014?
Your response must be concise. 1.09. What is the ratio of the Bank branche(per 100,000 adults) in Trinidad and Tobago in 2010 to that in 2014?
Your answer should be compact. 1. What is the ratio of the Bank branche(per 100,000 adults) in Cameroon in 2011 to that in 2012?
Give a very brief answer. 0.95. What is the ratio of the Bank branche(per 100,000 adults) in Mozambique in 2011 to that in 2012?
Provide a short and direct response. 0.94. What is the ratio of the Bank branche(per 100,000 adults) of Singapore in 2011 to that in 2012?
Provide a succinct answer. 1.02. What is the ratio of the Bank branche(per 100,000 adults) in Trinidad and Tobago in 2011 to that in 2012?
Make the answer very short. 0.99. What is the ratio of the Bank branche(per 100,000 adults) in Cameroon in 2011 to that in 2013?
Offer a very short reply. 0.88. What is the ratio of the Bank branche(per 100,000 adults) of Mozambique in 2011 to that in 2013?
Offer a very short reply. 0.93. What is the ratio of the Bank branche(per 100,000 adults) in Singapore in 2011 to that in 2013?
Your answer should be compact. 1.05. What is the ratio of the Bank branche(per 100,000 adults) in Cameroon in 2011 to that in 2014?
Your answer should be very brief. 0.87. What is the ratio of the Bank branche(per 100,000 adults) of Mozambique in 2011 to that in 2014?
Provide a succinct answer. 0.87. What is the ratio of the Bank branche(per 100,000 adults) of Singapore in 2011 to that in 2014?
Give a very brief answer. 1.06. What is the ratio of the Bank branche(per 100,000 adults) of Trinidad and Tobago in 2011 to that in 2014?
Make the answer very short. 0.93. What is the ratio of the Bank branche(per 100,000 adults) of Cameroon in 2012 to that in 2013?
Your response must be concise. 0.94. What is the ratio of the Bank branche(per 100,000 adults) in Singapore in 2012 to that in 2013?
Provide a succinct answer. 1.03. What is the ratio of the Bank branche(per 100,000 adults) of Trinidad and Tobago in 2012 to that in 2013?
Your response must be concise. 1.01. What is the ratio of the Bank branche(per 100,000 adults) in Cameroon in 2012 to that in 2014?
Ensure brevity in your answer.  0.92. What is the ratio of the Bank branche(per 100,000 adults) in Mozambique in 2012 to that in 2014?
Keep it short and to the point. 0.93. What is the ratio of the Bank branche(per 100,000 adults) of Singapore in 2012 to that in 2014?
Your response must be concise. 1.04. What is the ratio of the Bank branche(per 100,000 adults) in Trinidad and Tobago in 2012 to that in 2014?
Provide a succinct answer. 0.95. What is the ratio of the Bank branche(per 100,000 adults) in Cameroon in 2013 to that in 2014?
Your response must be concise. 0.99. What is the ratio of the Bank branche(per 100,000 adults) of Mozambique in 2013 to that in 2014?
Your answer should be compact. 0.94. What is the ratio of the Bank branche(per 100,000 adults) of Singapore in 2013 to that in 2014?
Ensure brevity in your answer.  1.01. What is the ratio of the Bank branche(per 100,000 adults) in Trinidad and Tobago in 2013 to that in 2014?
Your answer should be compact. 0.94. What is the difference between the highest and the second highest Bank branche(per 100,000 adults) in Cameroon?
Provide a short and direct response. 0.02. What is the difference between the highest and the second highest Bank branche(per 100,000 adults) in Mozambique?
Provide a succinct answer. 0.26. What is the difference between the highest and the second highest Bank branche(per 100,000 adults) of Singapore?
Offer a terse response. 0.01. What is the difference between the highest and the second highest Bank branche(per 100,000 adults) of Trinidad and Tobago?
Your answer should be very brief. 0.03. What is the difference between the highest and the lowest Bank branche(per 100,000 adults) in Cameroon?
Provide a succinct answer. 0.67. What is the difference between the highest and the lowest Bank branche(per 100,000 adults) in Mozambique?
Your answer should be very brief. 1.21. What is the difference between the highest and the lowest Bank branche(per 100,000 adults) of Singapore?
Provide a short and direct response. 0.87. What is the difference between the highest and the lowest Bank branche(per 100,000 adults) of Trinidad and Tobago?
Make the answer very short. 0.91. 